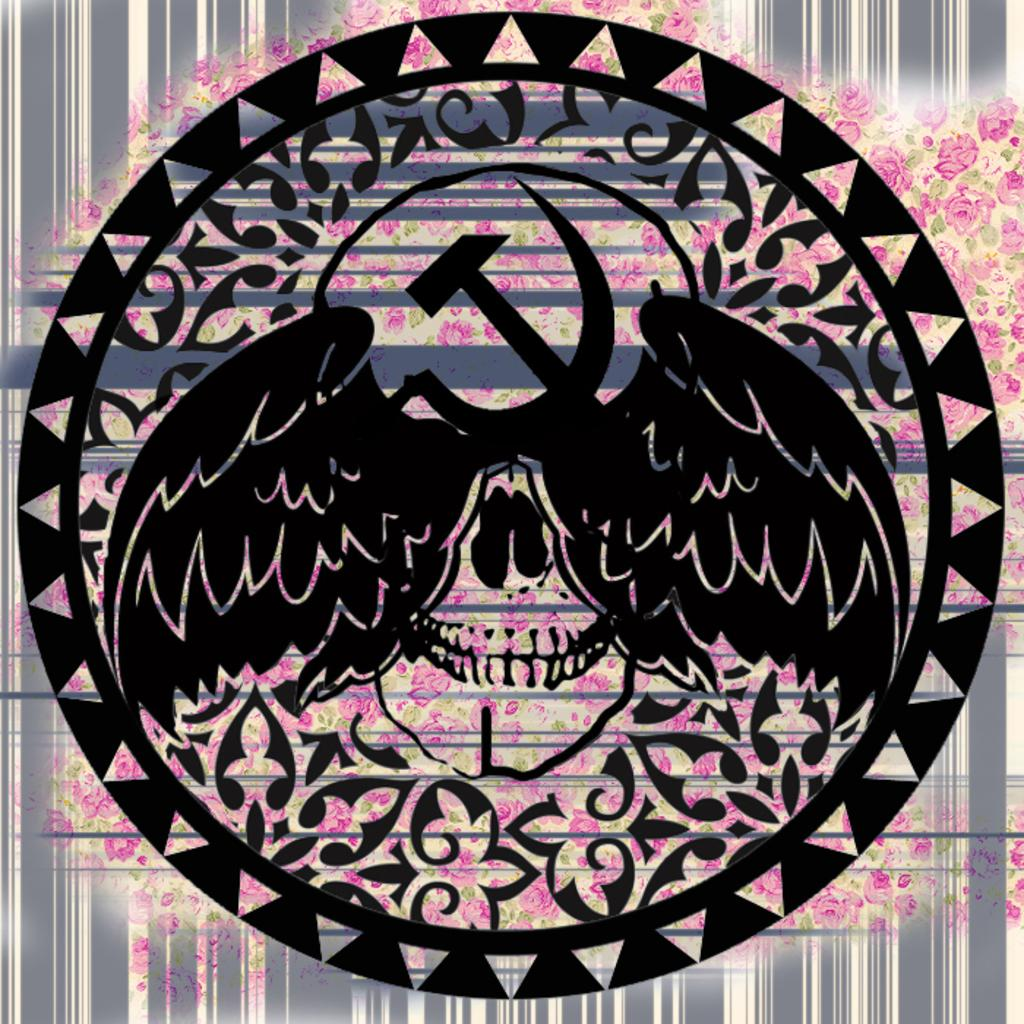What is the main subject of the image? The main subject of the image is a symbol. What type of polish is being applied to the toothpaste in the image? There is no toothpaste or polish present in the image; it only features a symbol. 